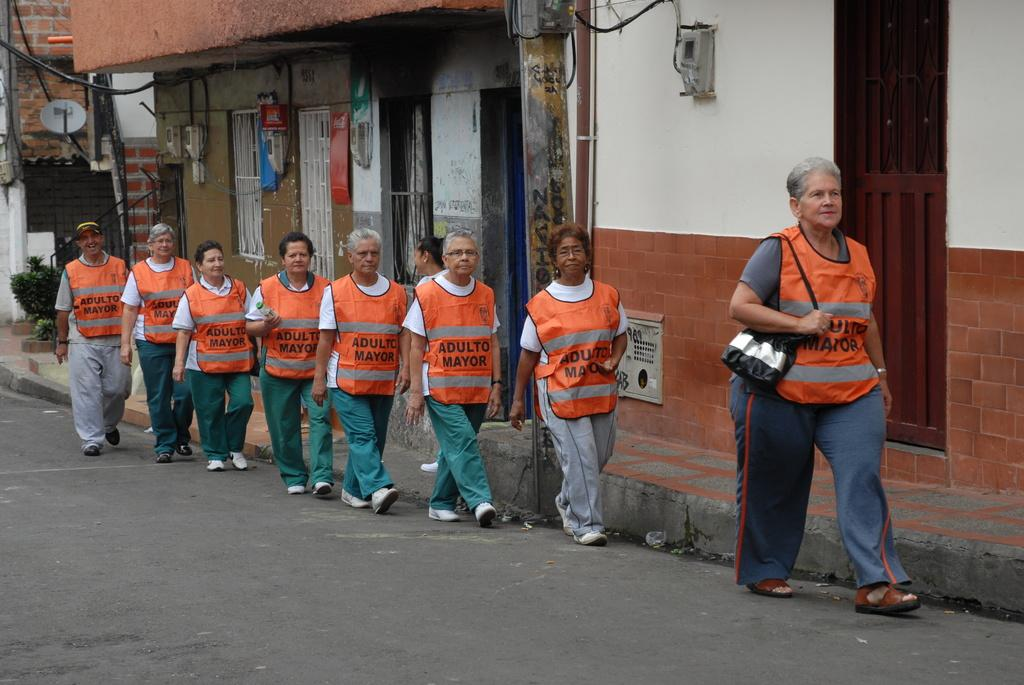What are the people in the image doing? The people in the image are standing in a queue. Where are the people located in the image? The people are on the road. What are the people wearing in the image? The people are wearing orange-colored coats. What can be seen in the background of the image? There is a building in the background of the image. What type of juice is being served at the front of the queue in the image? There is no juice or any indication of a service being provided in the image; it only shows people standing in a queue wearing orange-colored coats on the road. 